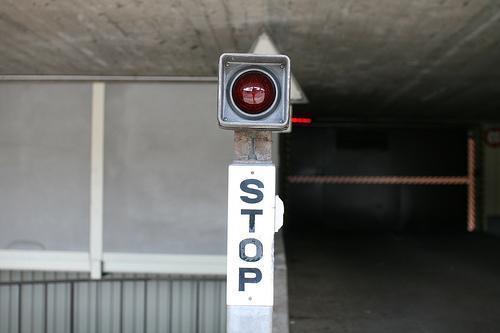How many signs are there?
Give a very brief answer. 1. 